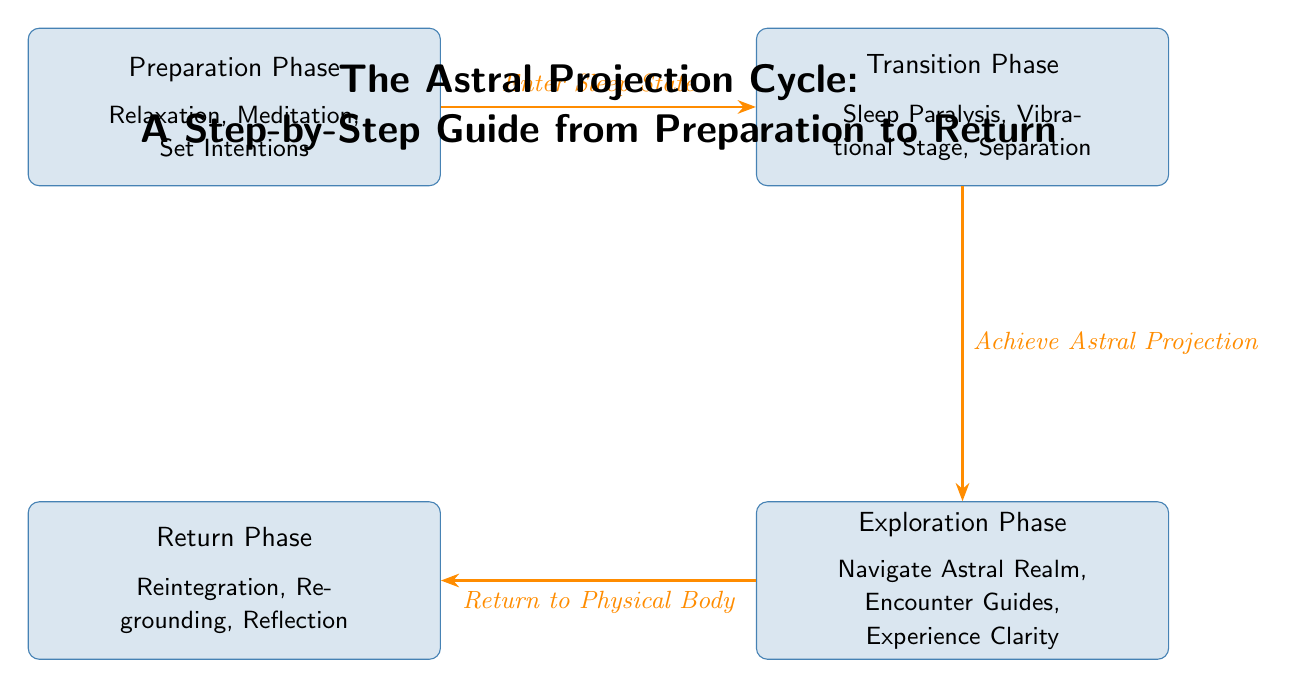What is the first phase in the Astral Projection Cycle? The first phase listed in the diagram is "Preparation Phase." This can be found as the leftmost node in the diagram.
Answer: Preparation Phase How many phases are there in the Astral Projection Cycle? The diagram lists four distinct phases: Preparation, Transition, Exploration, and Return. By counting the nodes, we can confirm this total.
Answer: 4 What happens after the Transition Phase? After the Transition Phase, the next phase is the Exploration Phase, indicated by the arrow leading downward from Transition to Exploration in the diagram.
Answer: Exploration Phase What is one activity listed under the Return Phase? One of the activities listed under the Return Phase is "Re-grounding." This is specifically mentioned within the text of the Return Phase node in the diagram.
Answer: Re-grounding Which phase involves navigating the astral realm? The Exploration Phase involves navigating the astral realm, as indicated by the description inside the Exploration Phase node in the diagram.
Answer: Exploration Phase What is the relationship between the Preparation Phase and the Transition Phase? The Preparation Phase leads into the Transition Phase, as shown by the arrow connecting these two nodes and labeled "Enter Sleep State."
Answer: Enter Sleep State What do you need to achieve to move from the Transition Phase to the Exploration Phase? To move from the Transition Phase to the Exploration Phase, you must "Achieve Astral Projection," which is indicated by the label on the arrow connecting these two phases.
Answer: Achieve Astral Projection What is a key focus during the Return Phase? A key focus during the Return Phase is "Reintegration," which is one of the elements noted in the description of that phase in the diagram.
Answer: Reintegration What is the last phase in the Astral Projection Cycle? The last phase in the cycle, as shown in the diagram, is the Return Phase, which is located at the bottom left of the visual representation.
Answer: Return Phase 